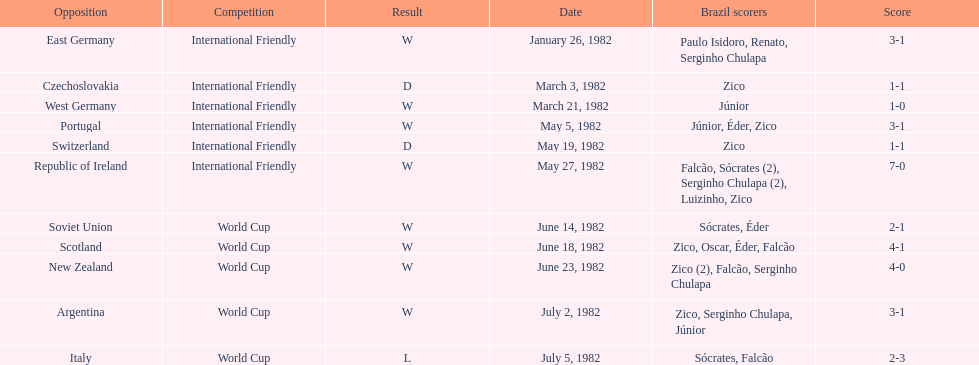How many times did brazil play west germany during the 1982 season? 1. 